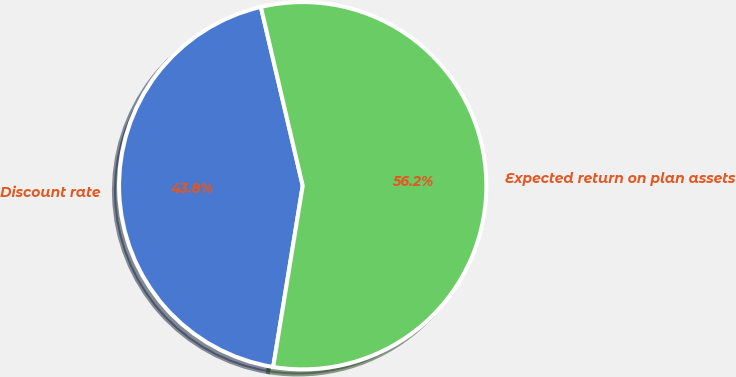Convert chart to OTSL. <chart><loc_0><loc_0><loc_500><loc_500><pie_chart><fcel>Discount rate<fcel>Expected return on plan assets<nl><fcel>43.77%<fcel>56.23%<nl></chart> 